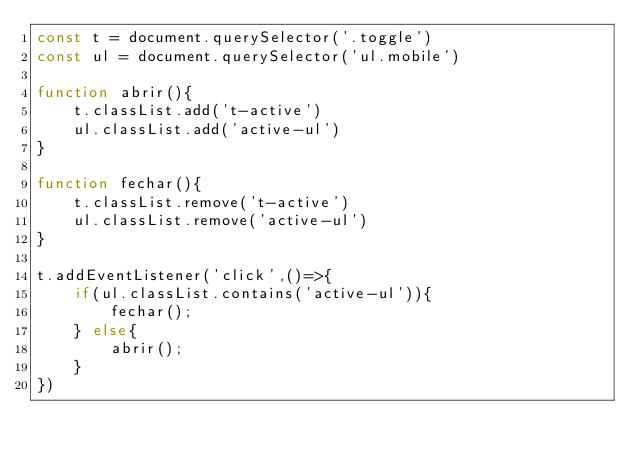<code> <loc_0><loc_0><loc_500><loc_500><_JavaScript_>const t = document.querySelector('.toggle')
const ul = document.querySelector('ul.mobile')

function abrir(){
    t.classList.add('t-active')
    ul.classList.add('active-ul')
}

function fechar(){
    t.classList.remove('t-active')
    ul.classList.remove('active-ul')
}

t.addEventListener('click',()=>{
    if(ul.classList.contains('active-ul')){
        fechar();
    } else{
        abrir();
    }
})</code> 